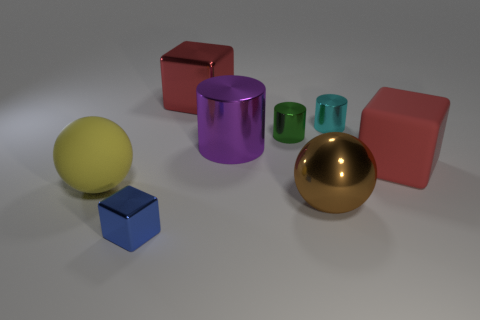What materials are the objects in the image made of, and what colors are they? The objects in the image appear to be made of two types of material. The sphere on the left looks like a matte-finished rubber, and it's yellow in color. The sphere on the right has a reflective surface, suggesting it's made out of metal with a golden hue. The cubes and the cylinders have a metallic look as well, coming in colors such as red, blue, purple, and different shades of green. 